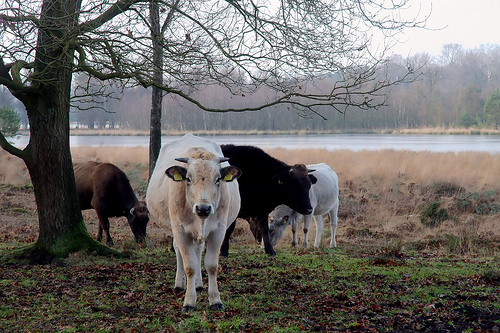<image>
Is there a cow behind the tree? No. The cow is not behind the tree. From this viewpoint, the cow appears to be positioned elsewhere in the scene. Where is the cow in relation to the tree? Is it in front of the tree? Yes. The cow is positioned in front of the tree, appearing closer to the camera viewpoint. 